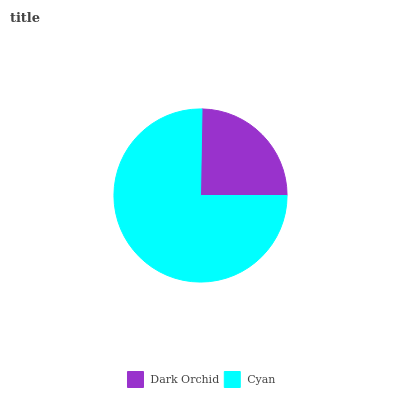Is Dark Orchid the minimum?
Answer yes or no. Yes. Is Cyan the maximum?
Answer yes or no. Yes. Is Cyan the minimum?
Answer yes or no. No. Is Cyan greater than Dark Orchid?
Answer yes or no. Yes. Is Dark Orchid less than Cyan?
Answer yes or no. Yes. Is Dark Orchid greater than Cyan?
Answer yes or no. No. Is Cyan less than Dark Orchid?
Answer yes or no. No. Is Cyan the high median?
Answer yes or no. Yes. Is Dark Orchid the low median?
Answer yes or no. Yes. Is Dark Orchid the high median?
Answer yes or no. No. Is Cyan the low median?
Answer yes or no. No. 